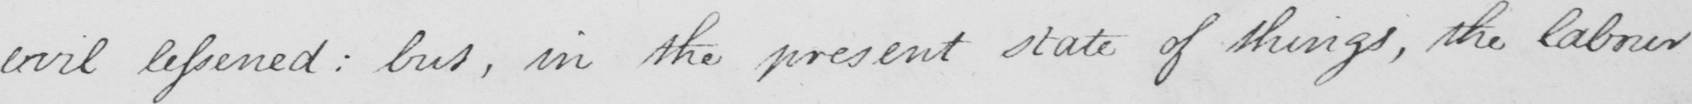Transcribe the text shown in this historical manuscript line. evil lessened :  but , in the present state of things , the labour 